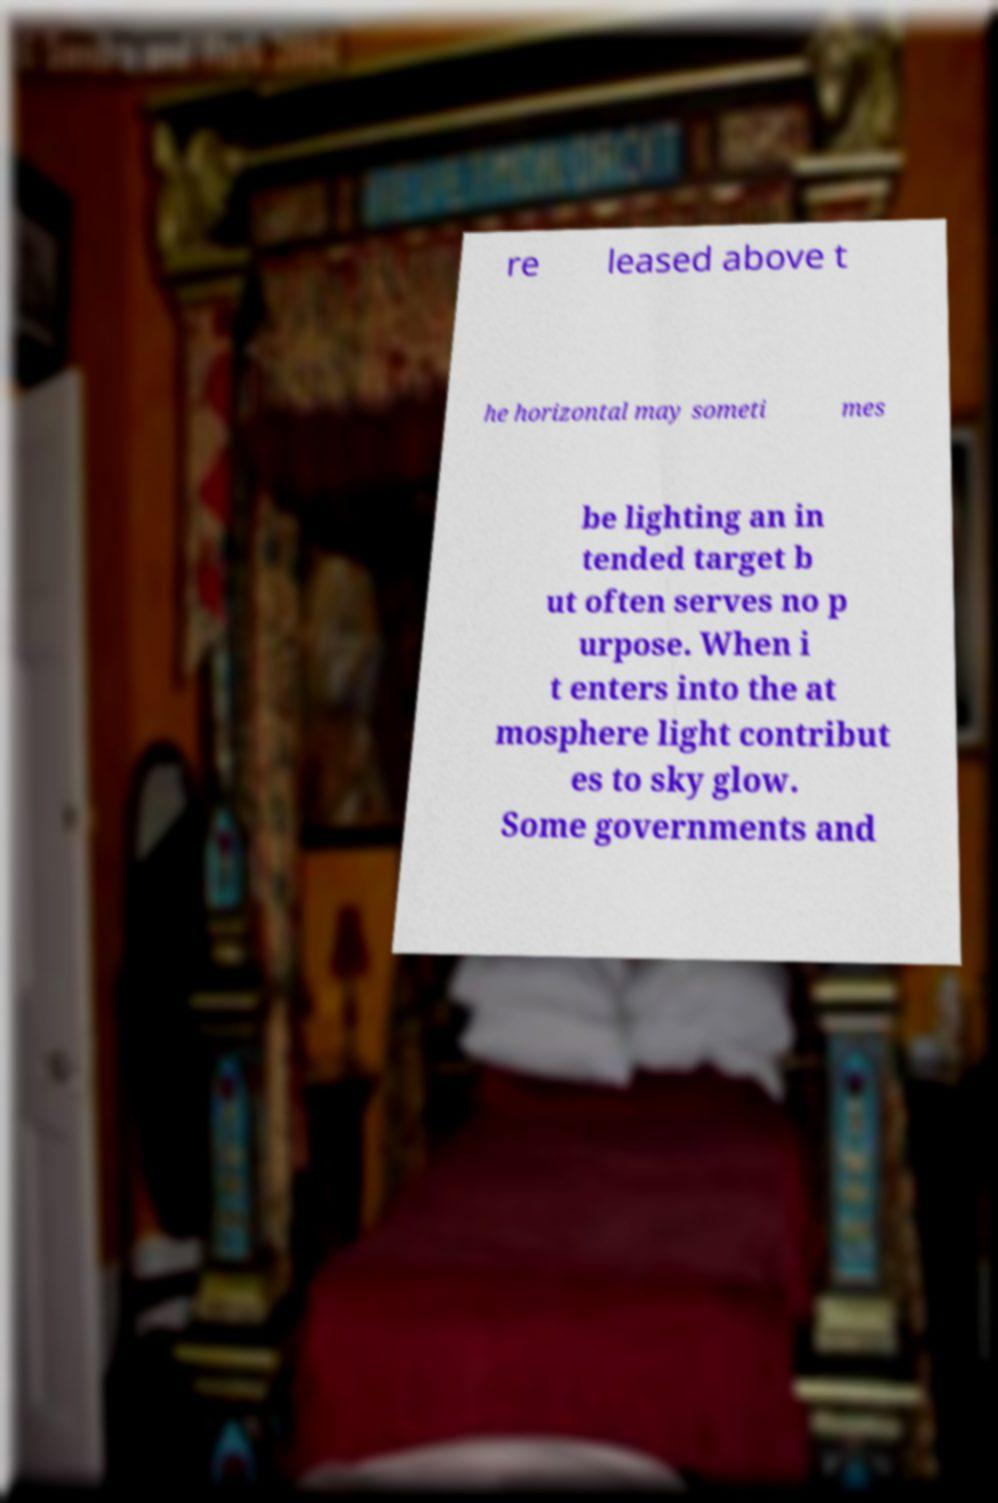Can you read and provide the text displayed in the image?This photo seems to have some interesting text. Can you extract and type it out for me? re leased above t he horizontal may someti mes be lighting an in tended target b ut often serves no p urpose. When i t enters into the at mosphere light contribut es to sky glow. Some governments and 